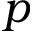<formula> <loc_0><loc_0><loc_500><loc_500>p</formula> 